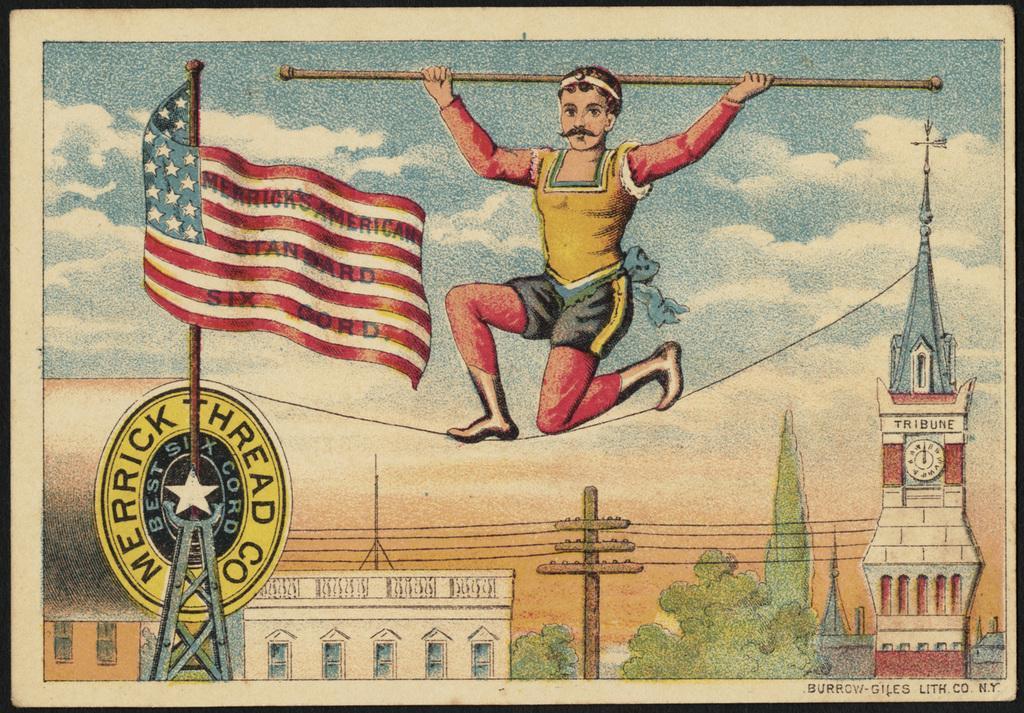Could you give a brief overview of what you see in this image? In this image there is a painting, in the painting there is a person holding a stick in his hand is standing on the road, in the background of the image there are trees, buildings, electric poles with cables on it, a flag and some object on the metal rods, at the top of the image there are clouds in the sky. 